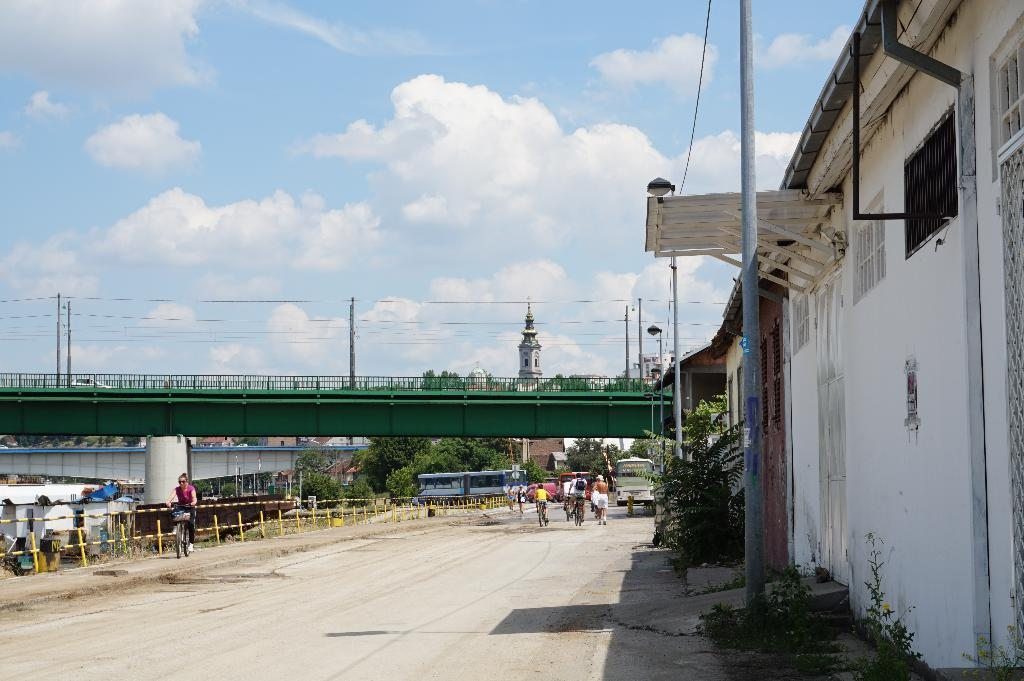What is located in the foreground of the image? There is a house and a pole in the foreground of the image. What can be seen in the background of the image? There are people, vehicles, buildings, poles, trees, a bridge, and the sky visible in the background of the image. What type of plantation can be seen in the background of the image? There is no plantation present in the image. How many yards are visible in the image? The concept of yards is not applicable in this context, as the image features a scene with various structures and objects, but not a yard. 